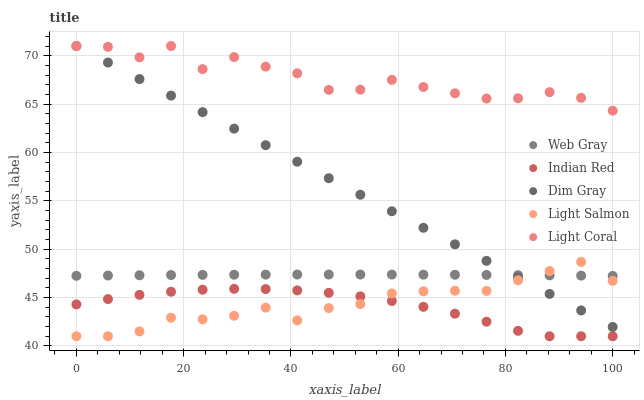Does Indian Red have the minimum area under the curve?
Answer yes or no. Yes. Does Light Coral have the maximum area under the curve?
Answer yes or no. Yes. Does Dim Gray have the minimum area under the curve?
Answer yes or no. No. Does Dim Gray have the maximum area under the curve?
Answer yes or no. No. Is Dim Gray the smoothest?
Answer yes or no. Yes. Is Light Coral the roughest?
Answer yes or no. Yes. Is Web Gray the smoothest?
Answer yes or no. No. Is Web Gray the roughest?
Answer yes or no. No. Does Light Salmon have the lowest value?
Answer yes or no. Yes. Does Dim Gray have the lowest value?
Answer yes or no. No. Does Dim Gray have the highest value?
Answer yes or no. Yes. Does Web Gray have the highest value?
Answer yes or no. No. Is Indian Red less than Web Gray?
Answer yes or no. Yes. Is Light Coral greater than Web Gray?
Answer yes or no. Yes. Does Indian Red intersect Light Salmon?
Answer yes or no. Yes. Is Indian Red less than Light Salmon?
Answer yes or no. No. Is Indian Red greater than Light Salmon?
Answer yes or no. No. Does Indian Red intersect Web Gray?
Answer yes or no. No. 